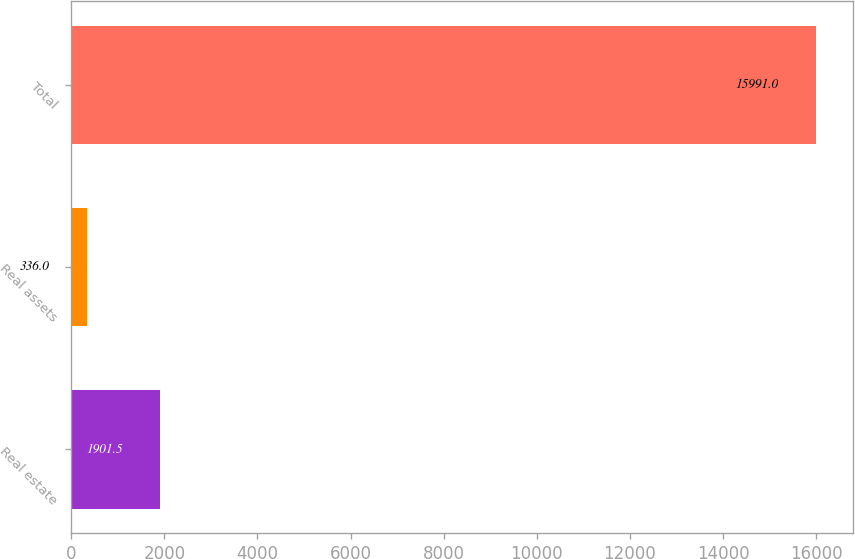Convert chart to OTSL. <chart><loc_0><loc_0><loc_500><loc_500><bar_chart><fcel>Real estate<fcel>Real assets<fcel>Total<nl><fcel>1901.5<fcel>336<fcel>15991<nl></chart> 